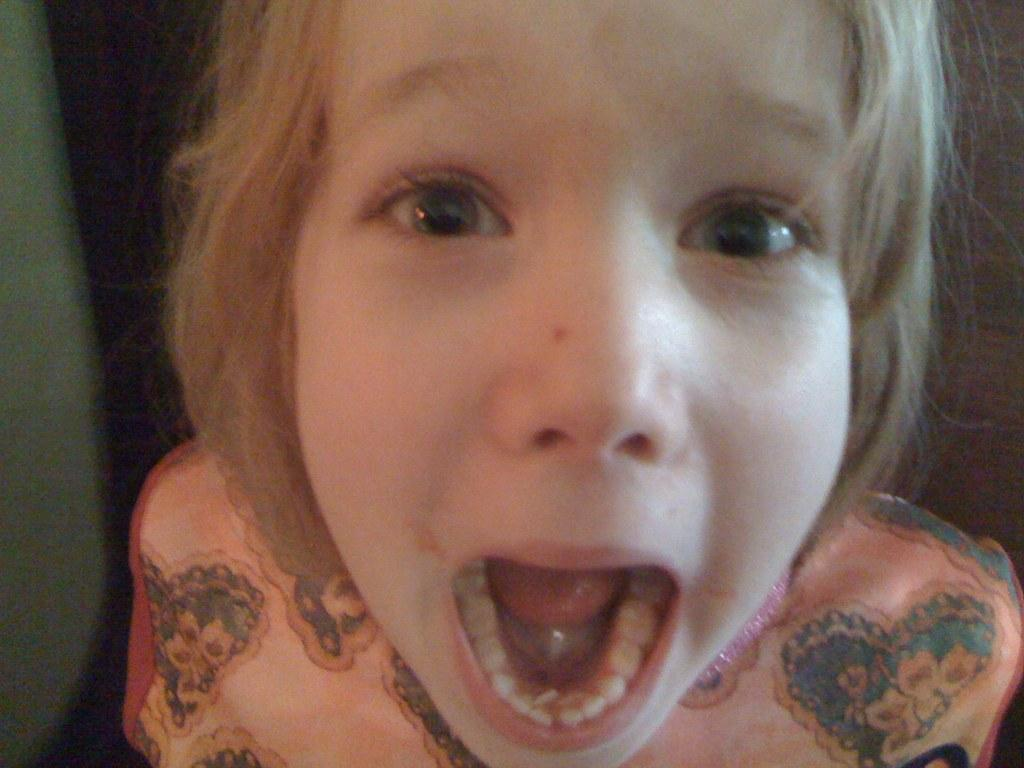What is the main subject of the image? There is a person in the image. What is the person wearing? The person is wearing a peach-colored dress. Can you describe the background of the image? The background of the image is dark. What type of fowl can be seen in the image? There is no fowl present in the image; it features a person wearing a peach-colored dress. What does the person's dad think about their outfit in the image? The provided facts do not mention the person's dad or their opinion about the outfit, so it cannot be determined from the image. 